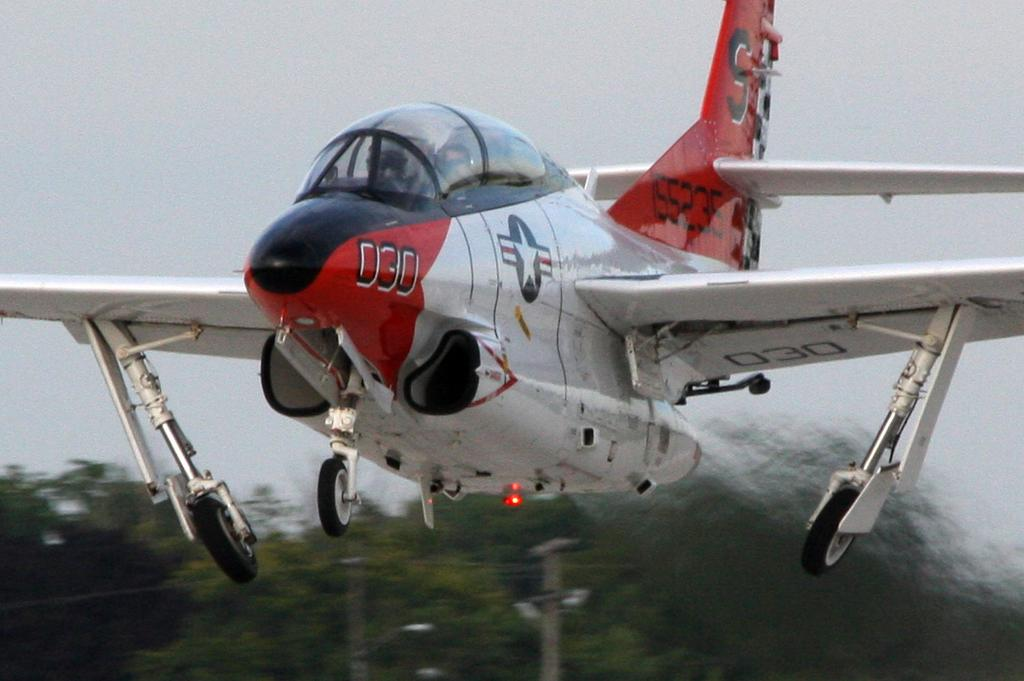<image>
Describe the image concisely. An airplane with the number 030 on the side and an S on the fin. 